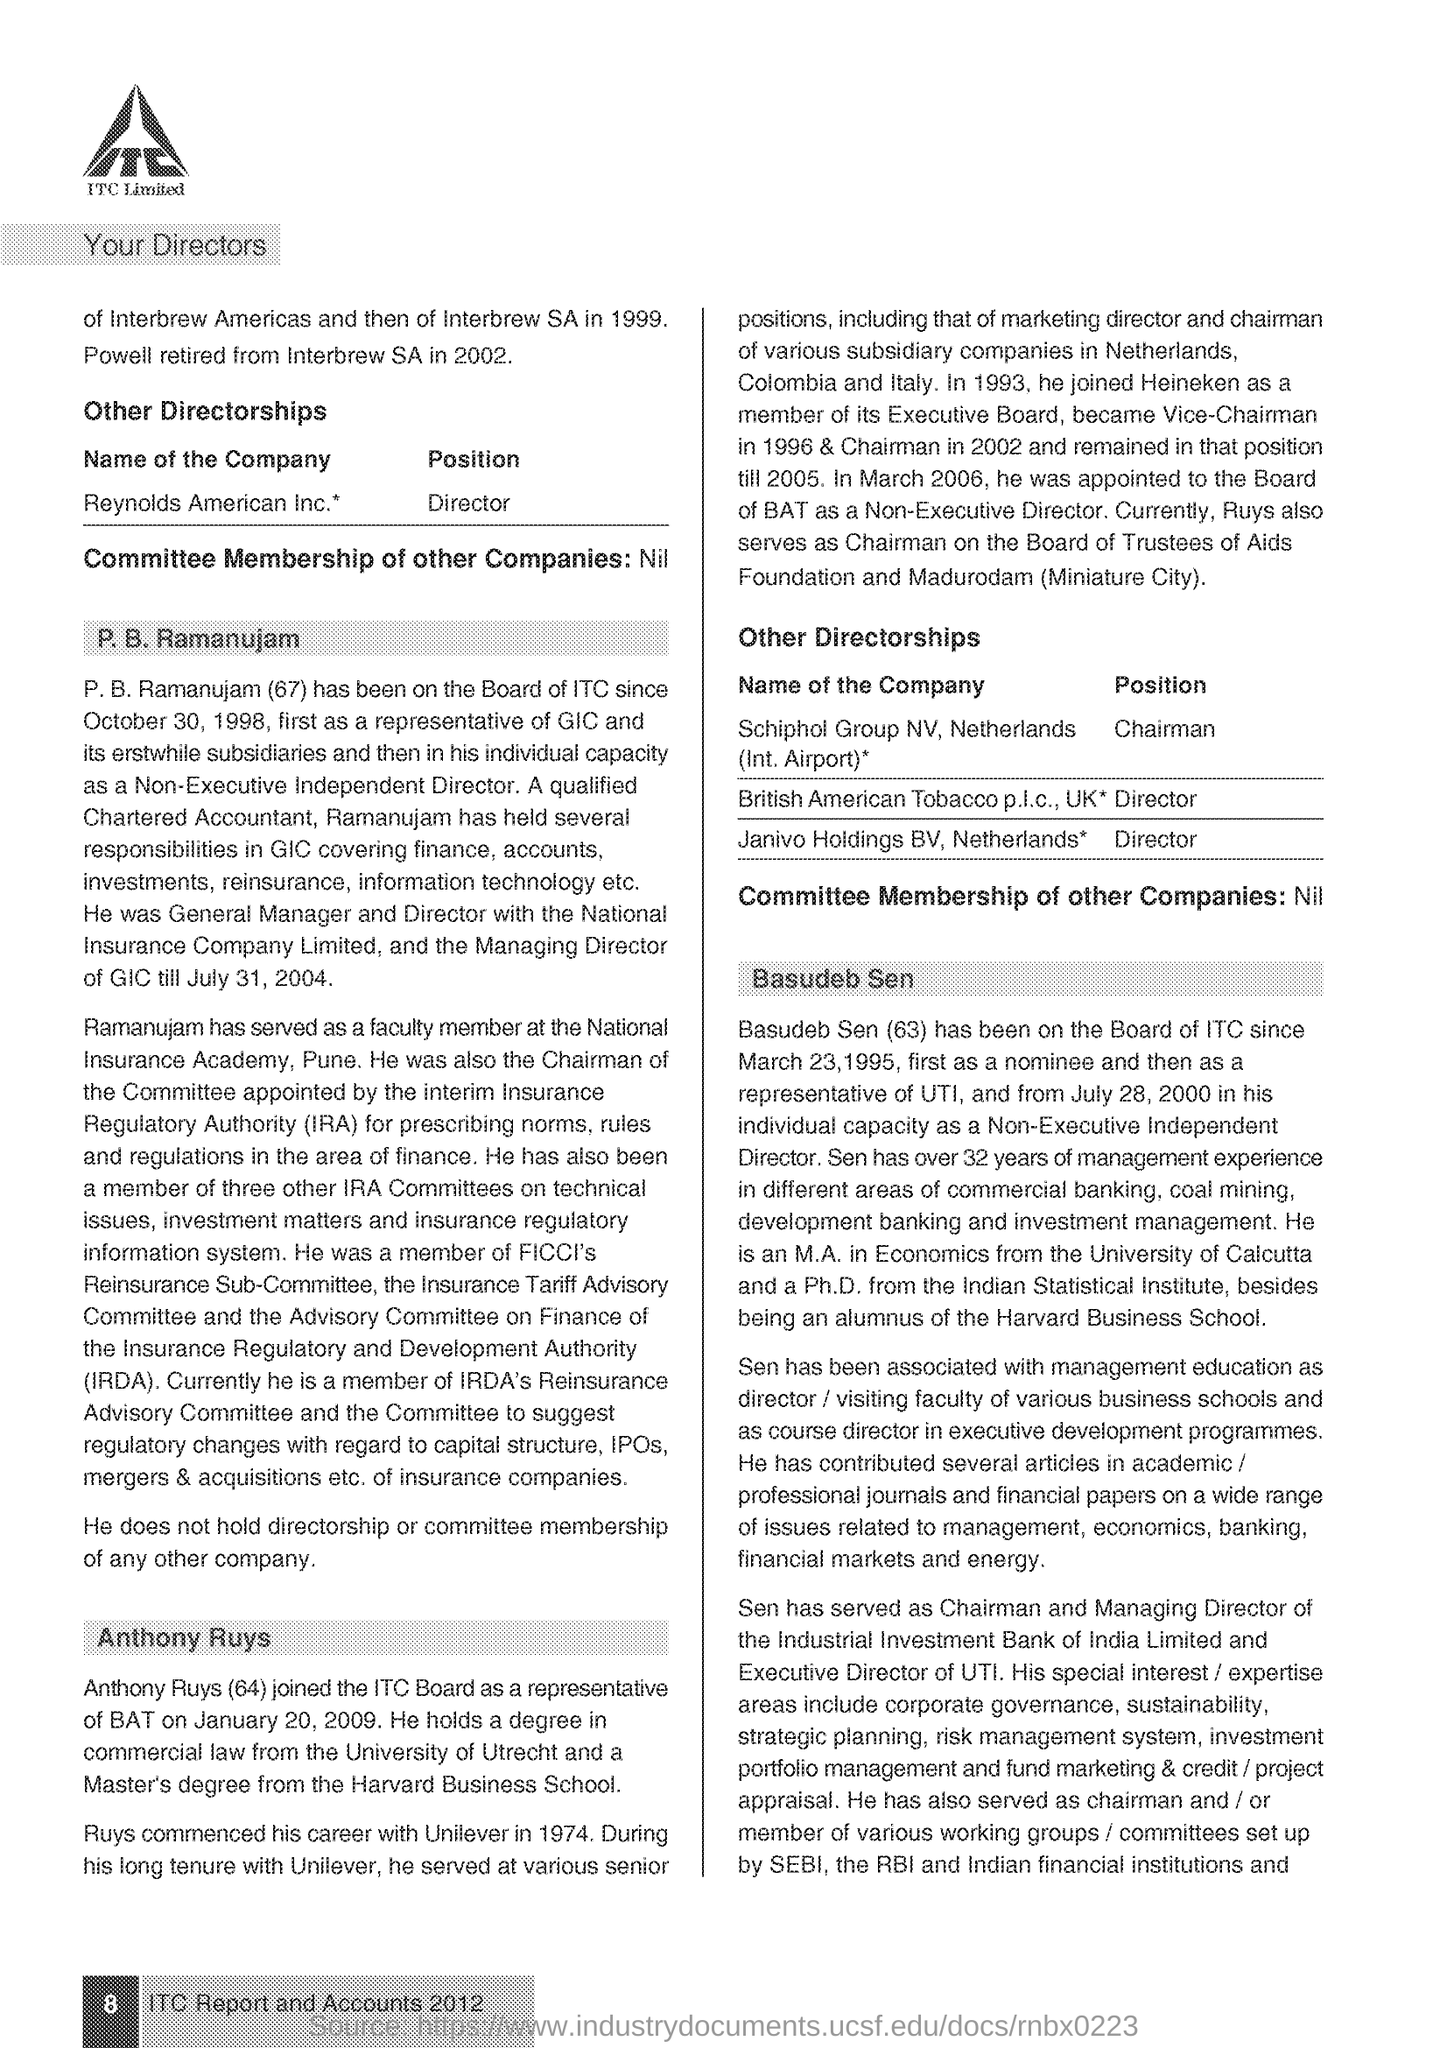Give some essential details in this illustration. The IRDA, or Insurance Regulatory and Development Authority, is a governing body responsible for regulating and developing the insurance industry in India. The fullform of IRA is Insurance Regulatory Authority. 